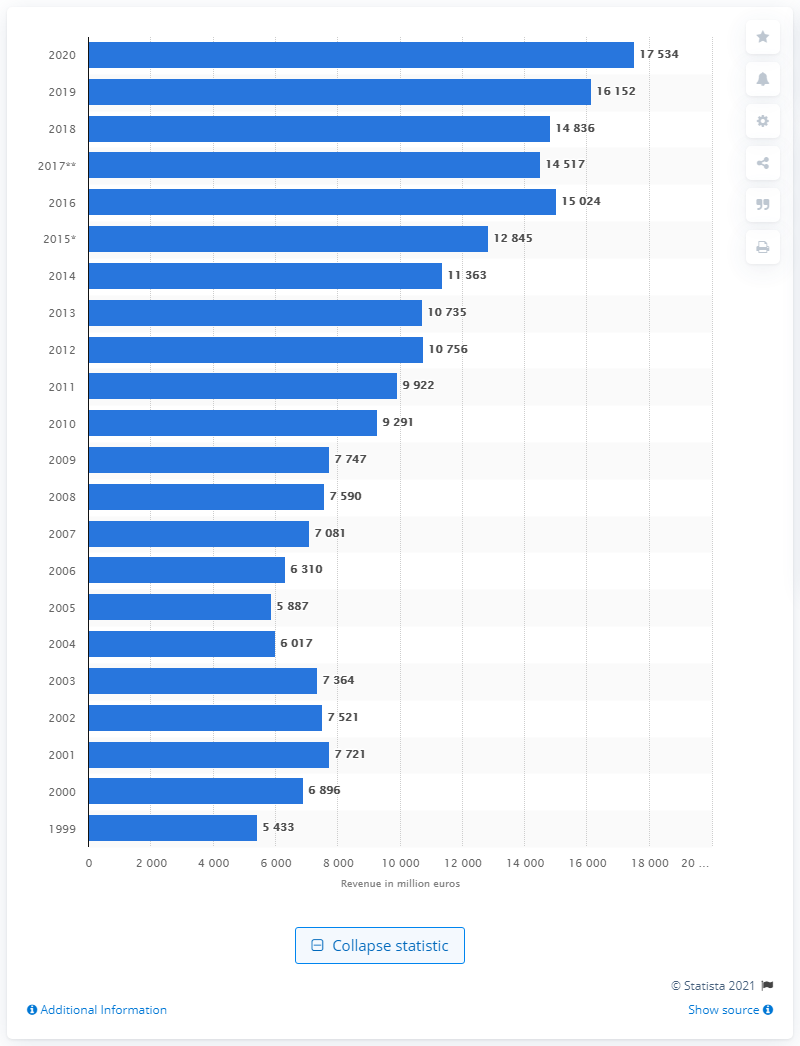Specify some key components in this picture. In 2020, the total revenue of Merck KGaA was 17,534. 